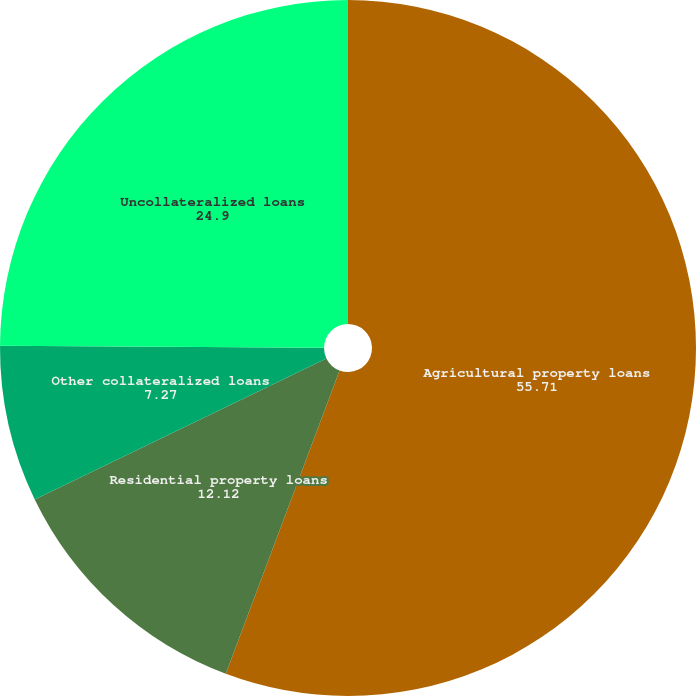Convert chart to OTSL. <chart><loc_0><loc_0><loc_500><loc_500><pie_chart><fcel>Agricultural property loans<fcel>Residential property loans<fcel>Other collateralized loans<fcel>Uncollateralized loans<nl><fcel>55.71%<fcel>12.12%<fcel>7.27%<fcel>24.9%<nl></chart> 